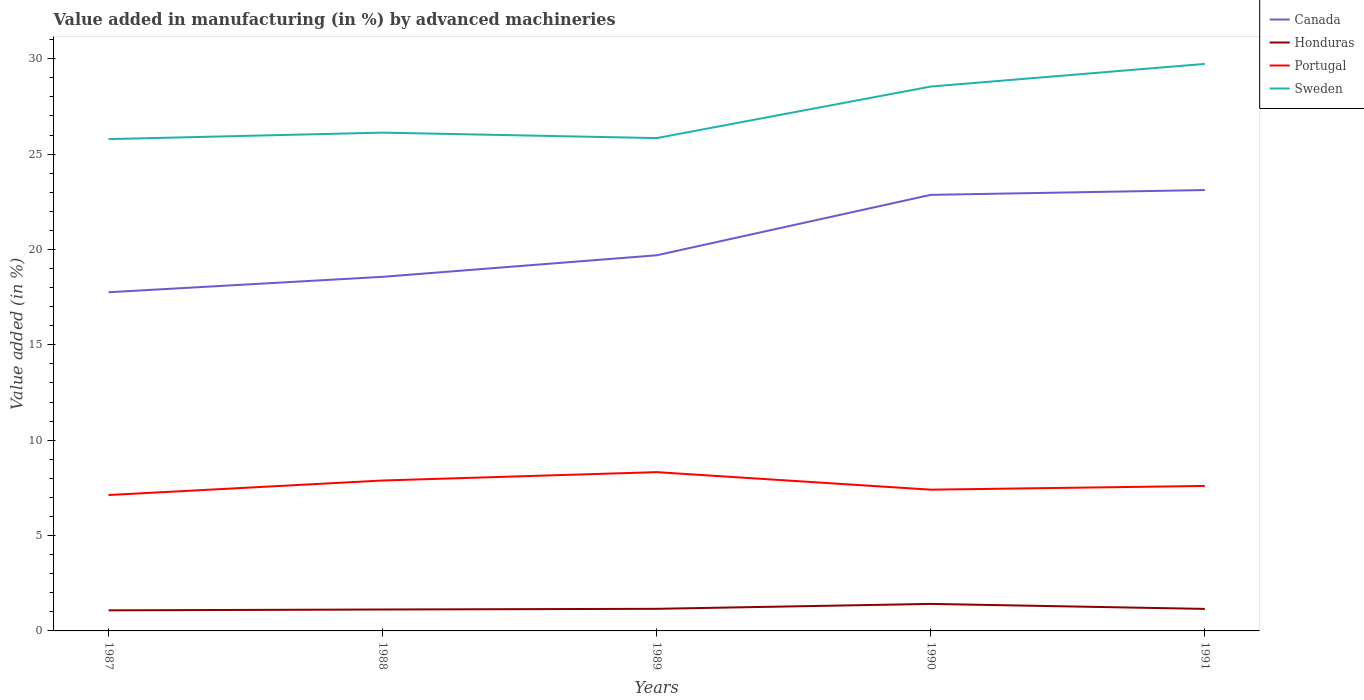Does the line corresponding to Sweden intersect with the line corresponding to Portugal?
Offer a terse response. No. Is the number of lines equal to the number of legend labels?
Your answer should be very brief. Yes. Across all years, what is the maximum percentage of value added in manufacturing by advanced machineries in Portugal?
Provide a short and direct response. 7.13. What is the total percentage of value added in manufacturing by advanced machineries in Honduras in the graph?
Provide a short and direct response. -0.26. What is the difference between the highest and the second highest percentage of value added in manufacturing by advanced machineries in Canada?
Your answer should be very brief. 5.36. What is the difference between the highest and the lowest percentage of value added in manufacturing by advanced machineries in Canada?
Offer a very short reply. 2. How many years are there in the graph?
Make the answer very short. 5. What is the difference between two consecutive major ticks on the Y-axis?
Your answer should be very brief. 5. Does the graph contain grids?
Provide a short and direct response. No. How are the legend labels stacked?
Your answer should be very brief. Vertical. What is the title of the graph?
Keep it short and to the point. Value added in manufacturing (in %) by advanced machineries. What is the label or title of the X-axis?
Offer a very short reply. Years. What is the label or title of the Y-axis?
Ensure brevity in your answer.  Value added (in %). What is the Value added (in %) in Canada in 1987?
Provide a short and direct response. 17.76. What is the Value added (in %) of Honduras in 1987?
Keep it short and to the point. 1.08. What is the Value added (in %) in Portugal in 1987?
Your response must be concise. 7.13. What is the Value added (in %) of Sweden in 1987?
Your answer should be compact. 25.79. What is the Value added (in %) in Canada in 1988?
Your answer should be compact. 18.57. What is the Value added (in %) of Honduras in 1988?
Offer a terse response. 1.12. What is the Value added (in %) in Portugal in 1988?
Offer a very short reply. 7.89. What is the Value added (in %) of Sweden in 1988?
Keep it short and to the point. 26.13. What is the Value added (in %) of Canada in 1989?
Offer a terse response. 19.7. What is the Value added (in %) of Honduras in 1989?
Keep it short and to the point. 1.16. What is the Value added (in %) in Portugal in 1989?
Provide a succinct answer. 8.33. What is the Value added (in %) in Sweden in 1989?
Your answer should be compact. 25.84. What is the Value added (in %) of Canada in 1990?
Make the answer very short. 22.86. What is the Value added (in %) of Honduras in 1990?
Your answer should be very brief. 1.42. What is the Value added (in %) of Portugal in 1990?
Keep it short and to the point. 7.41. What is the Value added (in %) of Sweden in 1990?
Your answer should be compact. 28.54. What is the Value added (in %) of Canada in 1991?
Your answer should be very brief. 23.12. What is the Value added (in %) in Honduras in 1991?
Your answer should be very brief. 1.15. What is the Value added (in %) of Portugal in 1991?
Keep it short and to the point. 7.6. What is the Value added (in %) in Sweden in 1991?
Offer a terse response. 29.73. Across all years, what is the maximum Value added (in %) in Canada?
Your response must be concise. 23.12. Across all years, what is the maximum Value added (in %) of Honduras?
Your response must be concise. 1.42. Across all years, what is the maximum Value added (in %) of Portugal?
Provide a short and direct response. 8.33. Across all years, what is the maximum Value added (in %) of Sweden?
Your response must be concise. 29.73. Across all years, what is the minimum Value added (in %) in Canada?
Offer a terse response. 17.76. Across all years, what is the minimum Value added (in %) of Honduras?
Your answer should be very brief. 1.08. Across all years, what is the minimum Value added (in %) of Portugal?
Provide a short and direct response. 7.13. Across all years, what is the minimum Value added (in %) in Sweden?
Provide a short and direct response. 25.79. What is the total Value added (in %) in Canada in the graph?
Make the answer very short. 102. What is the total Value added (in %) in Honduras in the graph?
Offer a very short reply. 5.93. What is the total Value added (in %) in Portugal in the graph?
Offer a very short reply. 38.35. What is the total Value added (in %) in Sweden in the graph?
Your response must be concise. 136.03. What is the difference between the Value added (in %) of Canada in 1987 and that in 1988?
Keep it short and to the point. -0.81. What is the difference between the Value added (in %) of Honduras in 1987 and that in 1988?
Your response must be concise. -0.04. What is the difference between the Value added (in %) in Portugal in 1987 and that in 1988?
Provide a short and direct response. -0.76. What is the difference between the Value added (in %) of Sweden in 1987 and that in 1988?
Give a very brief answer. -0.34. What is the difference between the Value added (in %) in Canada in 1987 and that in 1989?
Ensure brevity in your answer.  -1.94. What is the difference between the Value added (in %) in Honduras in 1987 and that in 1989?
Offer a very short reply. -0.08. What is the difference between the Value added (in %) of Portugal in 1987 and that in 1989?
Your response must be concise. -1.2. What is the difference between the Value added (in %) of Sweden in 1987 and that in 1989?
Give a very brief answer. -0.05. What is the difference between the Value added (in %) in Canada in 1987 and that in 1990?
Ensure brevity in your answer.  -5.11. What is the difference between the Value added (in %) of Honduras in 1987 and that in 1990?
Offer a terse response. -0.34. What is the difference between the Value added (in %) in Portugal in 1987 and that in 1990?
Your response must be concise. -0.28. What is the difference between the Value added (in %) of Sweden in 1987 and that in 1990?
Your answer should be compact. -2.76. What is the difference between the Value added (in %) in Canada in 1987 and that in 1991?
Your answer should be very brief. -5.36. What is the difference between the Value added (in %) of Honduras in 1987 and that in 1991?
Provide a succinct answer. -0.08. What is the difference between the Value added (in %) of Portugal in 1987 and that in 1991?
Provide a short and direct response. -0.48. What is the difference between the Value added (in %) in Sweden in 1987 and that in 1991?
Offer a terse response. -3.94. What is the difference between the Value added (in %) in Canada in 1988 and that in 1989?
Ensure brevity in your answer.  -1.13. What is the difference between the Value added (in %) in Honduras in 1988 and that in 1989?
Give a very brief answer. -0.04. What is the difference between the Value added (in %) in Portugal in 1988 and that in 1989?
Provide a short and direct response. -0.44. What is the difference between the Value added (in %) of Sweden in 1988 and that in 1989?
Make the answer very short. 0.29. What is the difference between the Value added (in %) of Canada in 1988 and that in 1990?
Offer a very short reply. -4.3. What is the difference between the Value added (in %) of Honduras in 1988 and that in 1990?
Your response must be concise. -0.29. What is the difference between the Value added (in %) in Portugal in 1988 and that in 1990?
Your answer should be compact. 0.48. What is the difference between the Value added (in %) of Sweden in 1988 and that in 1990?
Ensure brevity in your answer.  -2.42. What is the difference between the Value added (in %) of Canada in 1988 and that in 1991?
Provide a succinct answer. -4.55. What is the difference between the Value added (in %) in Honduras in 1988 and that in 1991?
Provide a short and direct response. -0.03. What is the difference between the Value added (in %) of Portugal in 1988 and that in 1991?
Offer a terse response. 0.28. What is the difference between the Value added (in %) of Sweden in 1988 and that in 1991?
Your answer should be very brief. -3.6. What is the difference between the Value added (in %) in Canada in 1989 and that in 1990?
Offer a very short reply. -3.17. What is the difference between the Value added (in %) of Honduras in 1989 and that in 1990?
Provide a short and direct response. -0.26. What is the difference between the Value added (in %) in Portugal in 1989 and that in 1990?
Provide a succinct answer. 0.92. What is the difference between the Value added (in %) in Sweden in 1989 and that in 1990?
Provide a succinct answer. -2.7. What is the difference between the Value added (in %) of Canada in 1989 and that in 1991?
Offer a very short reply. -3.42. What is the difference between the Value added (in %) in Honduras in 1989 and that in 1991?
Make the answer very short. 0. What is the difference between the Value added (in %) of Portugal in 1989 and that in 1991?
Make the answer very short. 0.72. What is the difference between the Value added (in %) of Sweden in 1989 and that in 1991?
Your answer should be very brief. -3.89. What is the difference between the Value added (in %) of Canada in 1990 and that in 1991?
Your answer should be very brief. -0.25. What is the difference between the Value added (in %) of Honduras in 1990 and that in 1991?
Offer a very short reply. 0.26. What is the difference between the Value added (in %) of Portugal in 1990 and that in 1991?
Offer a very short reply. -0.2. What is the difference between the Value added (in %) in Sweden in 1990 and that in 1991?
Ensure brevity in your answer.  -1.19. What is the difference between the Value added (in %) of Canada in 1987 and the Value added (in %) of Honduras in 1988?
Your response must be concise. 16.63. What is the difference between the Value added (in %) in Canada in 1987 and the Value added (in %) in Portugal in 1988?
Ensure brevity in your answer.  9.87. What is the difference between the Value added (in %) in Canada in 1987 and the Value added (in %) in Sweden in 1988?
Offer a very short reply. -8.37. What is the difference between the Value added (in %) in Honduras in 1987 and the Value added (in %) in Portugal in 1988?
Ensure brevity in your answer.  -6.81. What is the difference between the Value added (in %) in Honduras in 1987 and the Value added (in %) in Sweden in 1988?
Give a very brief answer. -25.05. What is the difference between the Value added (in %) of Portugal in 1987 and the Value added (in %) of Sweden in 1988?
Keep it short and to the point. -19. What is the difference between the Value added (in %) in Canada in 1987 and the Value added (in %) in Honduras in 1989?
Provide a short and direct response. 16.6. What is the difference between the Value added (in %) of Canada in 1987 and the Value added (in %) of Portugal in 1989?
Your answer should be compact. 9.43. What is the difference between the Value added (in %) in Canada in 1987 and the Value added (in %) in Sweden in 1989?
Provide a succinct answer. -8.08. What is the difference between the Value added (in %) of Honduras in 1987 and the Value added (in %) of Portugal in 1989?
Your answer should be compact. -7.25. What is the difference between the Value added (in %) of Honduras in 1987 and the Value added (in %) of Sweden in 1989?
Ensure brevity in your answer.  -24.76. What is the difference between the Value added (in %) of Portugal in 1987 and the Value added (in %) of Sweden in 1989?
Offer a terse response. -18.72. What is the difference between the Value added (in %) in Canada in 1987 and the Value added (in %) in Honduras in 1990?
Ensure brevity in your answer.  16.34. What is the difference between the Value added (in %) of Canada in 1987 and the Value added (in %) of Portugal in 1990?
Provide a succinct answer. 10.35. What is the difference between the Value added (in %) of Canada in 1987 and the Value added (in %) of Sweden in 1990?
Provide a succinct answer. -10.79. What is the difference between the Value added (in %) in Honduras in 1987 and the Value added (in %) in Portugal in 1990?
Give a very brief answer. -6.33. What is the difference between the Value added (in %) of Honduras in 1987 and the Value added (in %) of Sweden in 1990?
Keep it short and to the point. -27.47. What is the difference between the Value added (in %) of Portugal in 1987 and the Value added (in %) of Sweden in 1990?
Offer a very short reply. -21.42. What is the difference between the Value added (in %) in Canada in 1987 and the Value added (in %) in Honduras in 1991?
Keep it short and to the point. 16.6. What is the difference between the Value added (in %) of Canada in 1987 and the Value added (in %) of Portugal in 1991?
Ensure brevity in your answer.  10.16. What is the difference between the Value added (in %) in Canada in 1987 and the Value added (in %) in Sweden in 1991?
Keep it short and to the point. -11.97. What is the difference between the Value added (in %) of Honduras in 1987 and the Value added (in %) of Portugal in 1991?
Give a very brief answer. -6.52. What is the difference between the Value added (in %) of Honduras in 1987 and the Value added (in %) of Sweden in 1991?
Make the answer very short. -28.65. What is the difference between the Value added (in %) of Portugal in 1987 and the Value added (in %) of Sweden in 1991?
Offer a very short reply. -22.61. What is the difference between the Value added (in %) of Canada in 1988 and the Value added (in %) of Honduras in 1989?
Provide a succinct answer. 17.41. What is the difference between the Value added (in %) in Canada in 1988 and the Value added (in %) in Portugal in 1989?
Give a very brief answer. 10.24. What is the difference between the Value added (in %) in Canada in 1988 and the Value added (in %) in Sweden in 1989?
Your response must be concise. -7.27. What is the difference between the Value added (in %) of Honduras in 1988 and the Value added (in %) of Portugal in 1989?
Offer a very short reply. -7.2. What is the difference between the Value added (in %) in Honduras in 1988 and the Value added (in %) in Sweden in 1989?
Give a very brief answer. -24.72. What is the difference between the Value added (in %) in Portugal in 1988 and the Value added (in %) in Sweden in 1989?
Your answer should be compact. -17.95. What is the difference between the Value added (in %) of Canada in 1988 and the Value added (in %) of Honduras in 1990?
Provide a succinct answer. 17.15. What is the difference between the Value added (in %) in Canada in 1988 and the Value added (in %) in Portugal in 1990?
Provide a succinct answer. 11.16. What is the difference between the Value added (in %) in Canada in 1988 and the Value added (in %) in Sweden in 1990?
Your answer should be compact. -9.98. What is the difference between the Value added (in %) in Honduras in 1988 and the Value added (in %) in Portugal in 1990?
Offer a terse response. -6.28. What is the difference between the Value added (in %) of Honduras in 1988 and the Value added (in %) of Sweden in 1990?
Give a very brief answer. -27.42. What is the difference between the Value added (in %) of Portugal in 1988 and the Value added (in %) of Sweden in 1990?
Keep it short and to the point. -20.66. What is the difference between the Value added (in %) in Canada in 1988 and the Value added (in %) in Honduras in 1991?
Provide a short and direct response. 17.41. What is the difference between the Value added (in %) in Canada in 1988 and the Value added (in %) in Portugal in 1991?
Your response must be concise. 10.96. What is the difference between the Value added (in %) of Canada in 1988 and the Value added (in %) of Sweden in 1991?
Make the answer very short. -11.17. What is the difference between the Value added (in %) in Honduras in 1988 and the Value added (in %) in Portugal in 1991?
Keep it short and to the point. -6.48. What is the difference between the Value added (in %) in Honduras in 1988 and the Value added (in %) in Sweden in 1991?
Your answer should be very brief. -28.61. What is the difference between the Value added (in %) of Portugal in 1988 and the Value added (in %) of Sweden in 1991?
Your answer should be compact. -21.84. What is the difference between the Value added (in %) in Canada in 1989 and the Value added (in %) in Honduras in 1990?
Keep it short and to the point. 18.28. What is the difference between the Value added (in %) in Canada in 1989 and the Value added (in %) in Portugal in 1990?
Keep it short and to the point. 12.29. What is the difference between the Value added (in %) of Canada in 1989 and the Value added (in %) of Sweden in 1990?
Give a very brief answer. -8.85. What is the difference between the Value added (in %) in Honduras in 1989 and the Value added (in %) in Portugal in 1990?
Your response must be concise. -6.25. What is the difference between the Value added (in %) in Honduras in 1989 and the Value added (in %) in Sweden in 1990?
Ensure brevity in your answer.  -27.39. What is the difference between the Value added (in %) of Portugal in 1989 and the Value added (in %) of Sweden in 1990?
Provide a short and direct response. -20.22. What is the difference between the Value added (in %) in Canada in 1989 and the Value added (in %) in Honduras in 1991?
Ensure brevity in your answer.  18.54. What is the difference between the Value added (in %) of Canada in 1989 and the Value added (in %) of Portugal in 1991?
Ensure brevity in your answer.  12.09. What is the difference between the Value added (in %) of Canada in 1989 and the Value added (in %) of Sweden in 1991?
Make the answer very short. -10.04. What is the difference between the Value added (in %) of Honduras in 1989 and the Value added (in %) of Portugal in 1991?
Offer a very short reply. -6.44. What is the difference between the Value added (in %) in Honduras in 1989 and the Value added (in %) in Sweden in 1991?
Your response must be concise. -28.57. What is the difference between the Value added (in %) of Portugal in 1989 and the Value added (in %) of Sweden in 1991?
Keep it short and to the point. -21.41. What is the difference between the Value added (in %) in Canada in 1990 and the Value added (in %) in Honduras in 1991?
Your answer should be compact. 21.71. What is the difference between the Value added (in %) of Canada in 1990 and the Value added (in %) of Portugal in 1991?
Ensure brevity in your answer.  15.26. What is the difference between the Value added (in %) of Canada in 1990 and the Value added (in %) of Sweden in 1991?
Ensure brevity in your answer.  -6.87. What is the difference between the Value added (in %) of Honduras in 1990 and the Value added (in %) of Portugal in 1991?
Keep it short and to the point. -6.19. What is the difference between the Value added (in %) in Honduras in 1990 and the Value added (in %) in Sweden in 1991?
Provide a short and direct response. -28.32. What is the difference between the Value added (in %) of Portugal in 1990 and the Value added (in %) of Sweden in 1991?
Keep it short and to the point. -22.33. What is the average Value added (in %) in Canada per year?
Provide a short and direct response. 20.4. What is the average Value added (in %) of Honduras per year?
Provide a succinct answer. 1.19. What is the average Value added (in %) in Portugal per year?
Provide a short and direct response. 7.67. What is the average Value added (in %) of Sweden per year?
Ensure brevity in your answer.  27.21. In the year 1987, what is the difference between the Value added (in %) in Canada and Value added (in %) in Honduras?
Ensure brevity in your answer.  16.68. In the year 1987, what is the difference between the Value added (in %) of Canada and Value added (in %) of Portugal?
Make the answer very short. 10.63. In the year 1987, what is the difference between the Value added (in %) in Canada and Value added (in %) in Sweden?
Keep it short and to the point. -8.03. In the year 1987, what is the difference between the Value added (in %) in Honduras and Value added (in %) in Portugal?
Give a very brief answer. -6.05. In the year 1987, what is the difference between the Value added (in %) in Honduras and Value added (in %) in Sweden?
Ensure brevity in your answer.  -24.71. In the year 1987, what is the difference between the Value added (in %) of Portugal and Value added (in %) of Sweden?
Ensure brevity in your answer.  -18.66. In the year 1988, what is the difference between the Value added (in %) of Canada and Value added (in %) of Honduras?
Make the answer very short. 17.44. In the year 1988, what is the difference between the Value added (in %) in Canada and Value added (in %) in Portugal?
Offer a very short reply. 10.68. In the year 1988, what is the difference between the Value added (in %) of Canada and Value added (in %) of Sweden?
Make the answer very short. -7.56. In the year 1988, what is the difference between the Value added (in %) in Honduras and Value added (in %) in Portugal?
Your answer should be very brief. -6.76. In the year 1988, what is the difference between the Value added (in %) of Honduras and Value added (in %) of Sweden?
Offer a terse response. -25. In the year 1988, what is the difference between the Value added (in %) in Portugal and Value added (in %) in Sweden?
Provide a short and direct response. -18.24. In the year 1989, what is the difference between the Value added (in %) of Canada and Value added (in %) of Honduras?
Your answer should be very brief. 18.54. In the year 1989, what is the difference between the Value added (in %) of Canada and Value added (in %) of Portugal?
Make the answer very short. 11.37. In the year 1989, what is the difference between the Value added (in %) in Canada and Value added (in %) in Sweden?
Keep it short and to the point. -6.14. In the year 1989, what is the difference between the Value added (in %) of Honduras and Value added (in %) of Portugal?
Keep it short and to the point. -7.17. In the year 1989, what is the difference between the Value added (in %) in Honduras and Value added (in %) in Sweden?
Your answer should be very brief. -24.68. In the year 1989, what is the difference between the Value added (in %) of Portugal and Value added (in %) of Sweden?
Offer a very short reply. -17.52. In the year 1990, what is the difference between the Value added (in %) of Canada and Value added (in %) of Honduras?
Your answer should be compact. 21.45. In the year 1990, what is the difference between the Value added (in %) in Canada and Value added (in %) in Portugal?
Offer a terse response. 15.46. In the year 1990, what is the difference between the Value added (in %) in Canada and Value added (in %) in Sweden?
Your answer should be compact. -5.68. In the year 1990, what is the difference between the Value added (in %) of Honduras and Value added (in %) of Portugal?
Keep it short and to the point. -5.99. In the year 1990, what is the difference between the Value added (in %) in Honduras and Value added (in %) in Sweden?
Offer a terse response. -27.13. In the year 1990, what is the difference between the Value added (in %) of Portugal and Value added (in %) of Sweden?
Your answer should be very brief. -21.14. In the year 1991, what is the difference between the Value added (in %) of Canada and Value added (in %) of Honduras?
Your answer should be compact. 21.96. In the year 1991, what is the difference between the Value added (in %) of Canada and Value added (in %) of Portugal?
Provide a short and direct response. 15.52. In the year 1991, what is the difference between the Value added (in %) of Canada and Value added (in %) of Sweden?
Your answer should be compact. -6.61. In the year 1991, what is the difference between the Value added (in %) in Honduras and Value added (in %) in Portugal?
Provide a short and direct response. -6.45. In the year 1991, what is the difference between the Value added (in %) in Honduras and Value added (in %) in Sweden?
Ensure brevity in your answer.  -28.58. In the year 1991, what is the difference between the Value added (in %) of Portugal and Value added (in %) of Sweden?
Your response must be concise. -22.13. What is the ratio of the Value added (in %) of Canada in 1987 to that in 1988?
Offer a very short reply. 0.96. What is the ratio of the Value added (in %) of Honduras in 1987 to that in 1988?
Make the answer very short. 0.96. What is the ratio of the Value added (in %) in Portugal in 1987 to that in 1988?
Provide a succinct answer. 0.9. What is the ratio of the Value added (in %) in Sweden in 1987 to that in 1988?
Offer a terse response. 0.99. What is the ratio of the Value added (in %) in Canada in 1987 to that in 1989?
Your answer should be compact. 0.9. What is the ratio of the Value added (in %) in Honduras in 1987 to that in 1989?
Make the answer very short. 0.93. What is the ratio of the Value added (in %) in Portugal in 1987 to that in 1989?
Your answer should be compact. 0.86. What is the ratio of the Value added (in %) of Canada in 1987 to that in 1990?
Make the answer very short. 0.78. What is the ratio of the Value added (in %) of Honduras in 1987 to that in 1990?
Make the answer very short. 0.76. What is the ratio of the Value added (in %) of Portugal in 1987 to that in 1990?
Provide a short and direct response. 0.96. What is the ratio of the Value added (in %) of Sweden in 1987 to that in 1990?
Ensure brevity in your answer.  0.9. What is the ratio of the Value added (in %) of Canada in 1987 to that in 1991?
Your response must be concise. 0.77. What is the ratio of the Value added (in %) in Honduras in 1987 to that in 1991?
Make the answer very short. 0.93. What is the ratio of the Value added (in %) in Portugal in 1987 to that in 1991?
Provide a succinct answer. 0.94. What is the ratio of the Value added (in %) of Sweden in 1987 to that in 1991?
Your answer should be compact. 0.87. What is the ratio of the Value added (in %) in Canada in 1988 to that in 1989?
Your response must be concise. 0.94. What is the ratio of the Value added (in %) of Honduras in 1988 to that in 1989?
Offer a terse response. 0.97. What is the ratio of the Value added (in %) in Portugal in 1988 to that in 1989?
Provide a short and direct response. 0.95. What is the ratio of the Value added (in %) in Sweden in 1988 to that in 1989?
Ensure brevity in your answer.  1.01. What is the ratio of the Value added (in %) of Canada in 1988 to that in 1990?
Provide a short and direct response. 0.81. What is the ratio of the Value added (in %) in Honduras in 1988 to that in 1990?
Ensure brevity in your answer.  0.79. What is the ratio of the Value added (in %) in Portugal in 1988 to that in 1990?
Your answer should be compact. 1.06. What is the ratio of the Value added (in %) of Sweden in 1988 to that in 1990?
Keep it short and to the point. 0.92. What is the ratio of the Value added (in %) of Canada in 1988 to that in 1991?
Your answer should be compact. 0.8. What is the ratio of the Value added (in %) of Honduras in 1988 to that in 1991?
Provide a succinct answer. 0.97. What is the ratio of the Value added (in %) in Portugal in 1988 to that in 1991?
Offer a very short reply. 1.04. What is the ratio of the Value added (in %) of Sweden in 1988 to that in 1991?
Make the answer very short. 0.88. What is the ratio of the Value added (in %) of Canada in 1989 to that in 1990?
Your response must be concise. 0.86. What is the ratio of the Value added (in %) in Honduras in 1989 to that in 1990?
Offer a terse response. 0.82. What is the ratio of the Value added (in %) of Portugal in 1989 to that in 1990?
Ensure brevity in your answer.  1.12. What is the ratio of the Value added (in %) of Sweden in 1989 to that in 1990?
Provide a succinct answer. 0.91. What is the ratio of the Value added (in %) of Canada in 1989 to that in 1991?
Offer a very short reply. 0.85. What is the ratio of the Value added (in %) in Portugal in 1989 to that in 1991?
Your answer should be compact. 1.1. What is the ratio of the Value added (in %) in Sweden in 1989 to that in 1991?
Make the answer very short. 0.87. What is the ratio of the Value added (in %) in Canada in 1990 to that in 1991?
Offer a terse response. 0.99. What is the ratio of the Value added (in %) in Honduras in 1990 to that in 1991?
Provide a succinct answer. 1.23. What is the ratio of the Value added (in %) in Portugal in 1990 to that in 1991?
Your answer should be very brief. 0.97. What is the ratio of the Value added (in %) in Sweden in 1990 to that in 1991?
Keep it short and to the point. 0.96. What is the difference between the highest and the second highest Value added (in %) in Canada?
Keep it short and to the point. 0.25. What is the difference between the highest and the second highest Value added (in %) in Honduras?
Provide a succinct answer. 0.26. What is the difference between the highest and the second highest Value added (in %) of Portugal?
Your answer should be compact. 0.44. What is the difference between the highest and the second highest Value added (in %) of Sweden?
Ensure brevity in your answer.  1.19. What is the difference between the highest and the lowest Value added (in %) in Canada?
Offer a very short reply. 5.36. What is the difference between the highest and the lowest Value added (in %) in Honduras?
Ensure brevity in your answer.  0.34. What is the difference between the highest and the lowest Value added (in %) in Portugal?
Keep it short and to the point. 1.2. What is the difference between the highest and the lowest Value added (in %) in Sweden?
Keep it short and to the point. 3.94. 